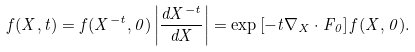<formula> <loc_0><loc_0><loc_500><loc_500>f ( X , t ) = f ( X ^ { - t } , 0 ) \left | \frac { d X ^ { - t } } { d X } \right | = \exp \left [ - t \nabla _ { X } \cdot { F } _ { 0 } \right ] f ( X , 0 ) .</formula> 